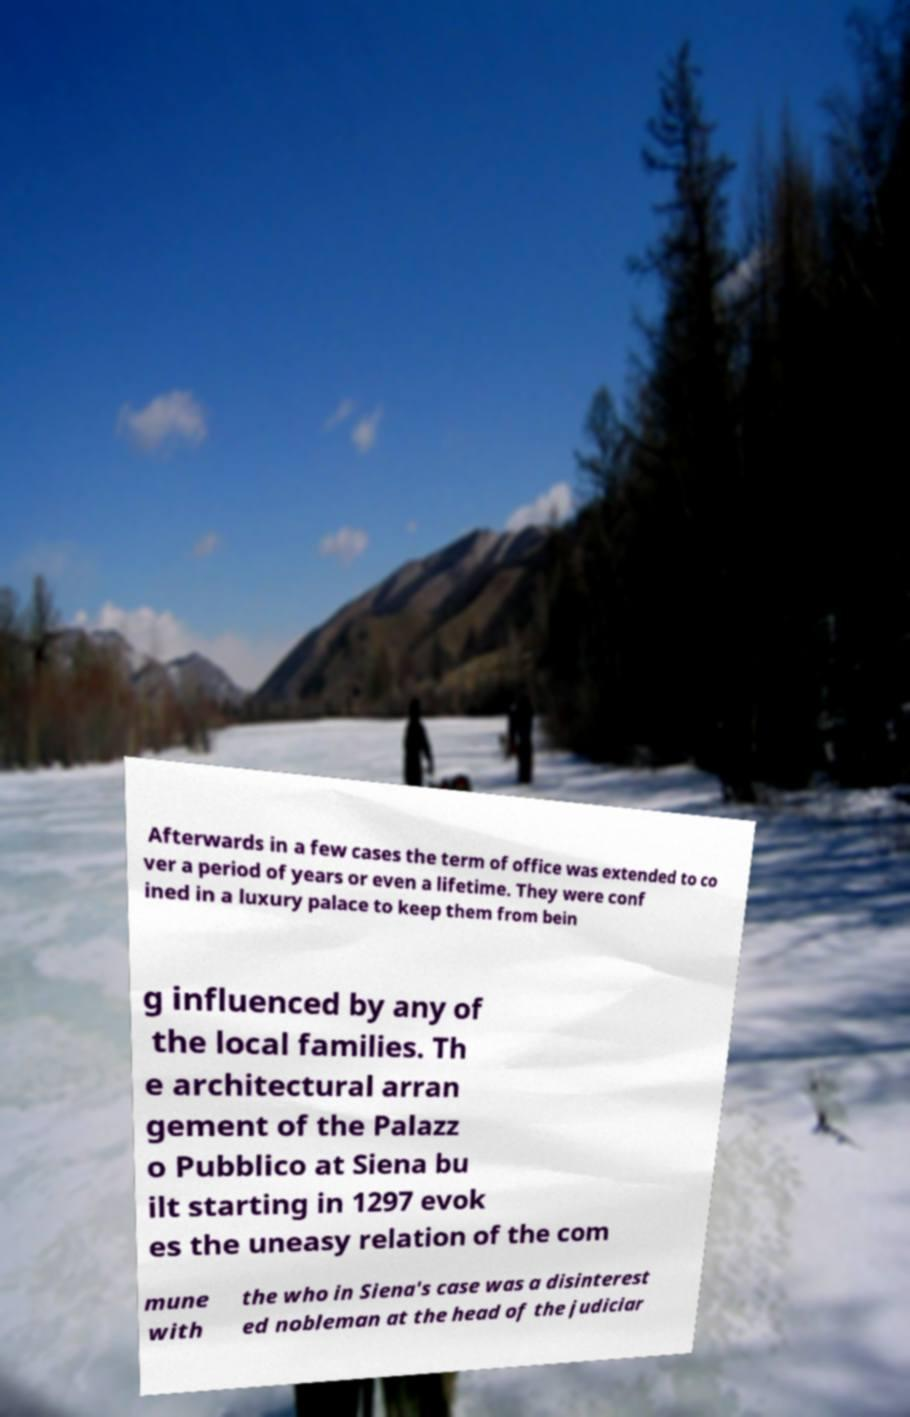I need the written content from this picture converted into text. Can you do that? Afterwards in a few cases the term of office was extended to co ver a period of years or even a lifetime. They were conf ined in a luxury palace to keep them from bein g influenced by any of the local families. Th e architectural arran gement of the Palazz o Pubblico at Siena bu ilt starting in 1297 evok es the uneasy relation of the com mune with the who in Siena's case was a disinterest ed nobleman at the head of the judiciar 